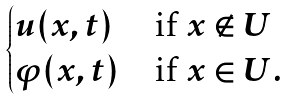<formula> <loc_0><loc_0><loc_500><loc_500>\begin{cases} u ( x , t ) & \text {if } x \notin U \\ \varphi ( x , t ) & \text {if } x \in U . \end{cases}</formula> 